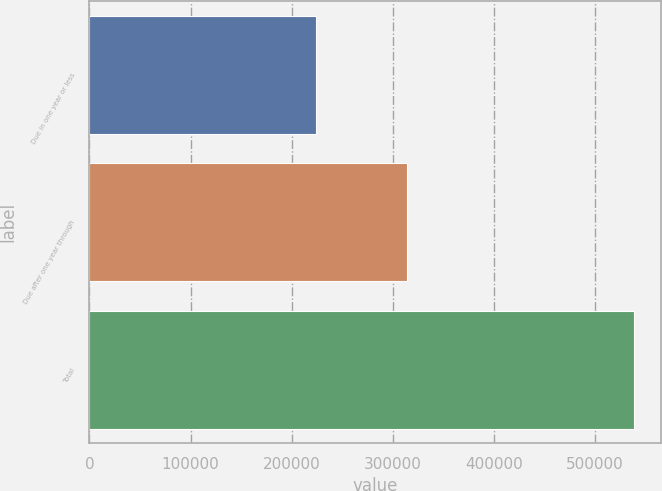Convert chart. <chart><loc_0><loc_0><loc_500><loc_500><bar_chart><fcel>Due in one year or less<fcel>Due after one year through<fcel>Total<nl><fcel>224414<fcel>313692<fcel>538106<nl></chart> 